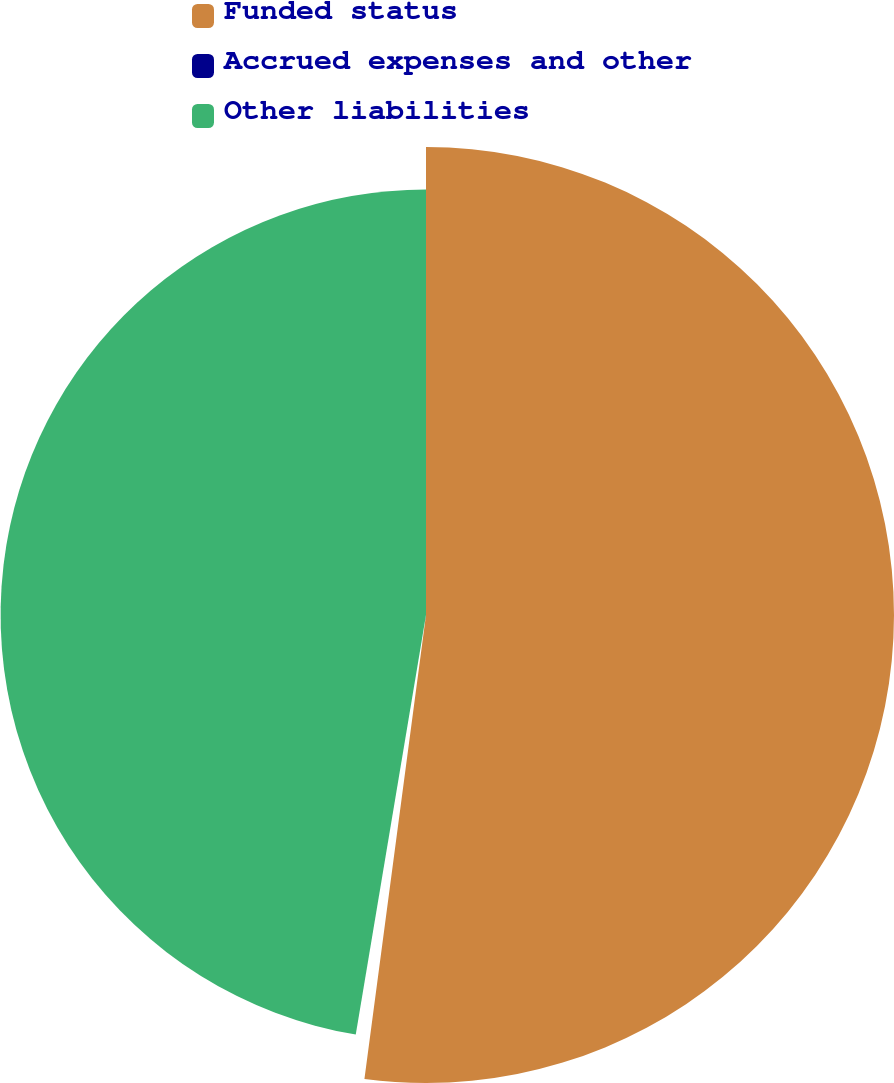Convert chart to OTSL. <chart><loc_0><loc_0><loc_500><loc_500><pie_chart><fcel>Funded status<fcel>Accrued expenses and other<fcel>Other liabilities<nl><fcel>52.1%<fcel>0.54%<fcel>47.36%<nl></chart> 